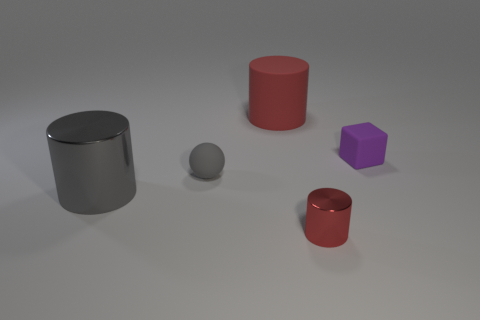What number of matte things are either big gray cylinders or tiny objects?
Your answer should be very brief. 2. Are there any purple things in front of the large object that is to the left of the red thing that is behind the tiny ball?
Provide a short and direct response. No. What is the color of the rubber cylinder?
Keep it short and to the point. Red. Is the shape of the tiny object that is to the left of the red shiny thing the same as  the tiny metal thing?
Your answer should be very brief. No. What number of things are small red cylinders or objects that are on the right side of the small matte ball?
Provide a succinct answer. 3. Is the cylinder to the left of the tiny gray rubber thing made of the same material as the small red thing?
Make the answer very short. Yes. Are there any other things that have the same size as the purple matte thing?
Offer a terse response. Yes. There is a red object in front of the small rubber object on the left side of the red metal object; what is it made of?
Your response must be concise. Metal. Are there more tiny red metal cylinders that are in front of the big gray shiny cylinder than small gray matte balls that are to the left of the small gray object?
Give a very brief answer. Yes. What size is the purple cube?
Make the answer very short. Small. 